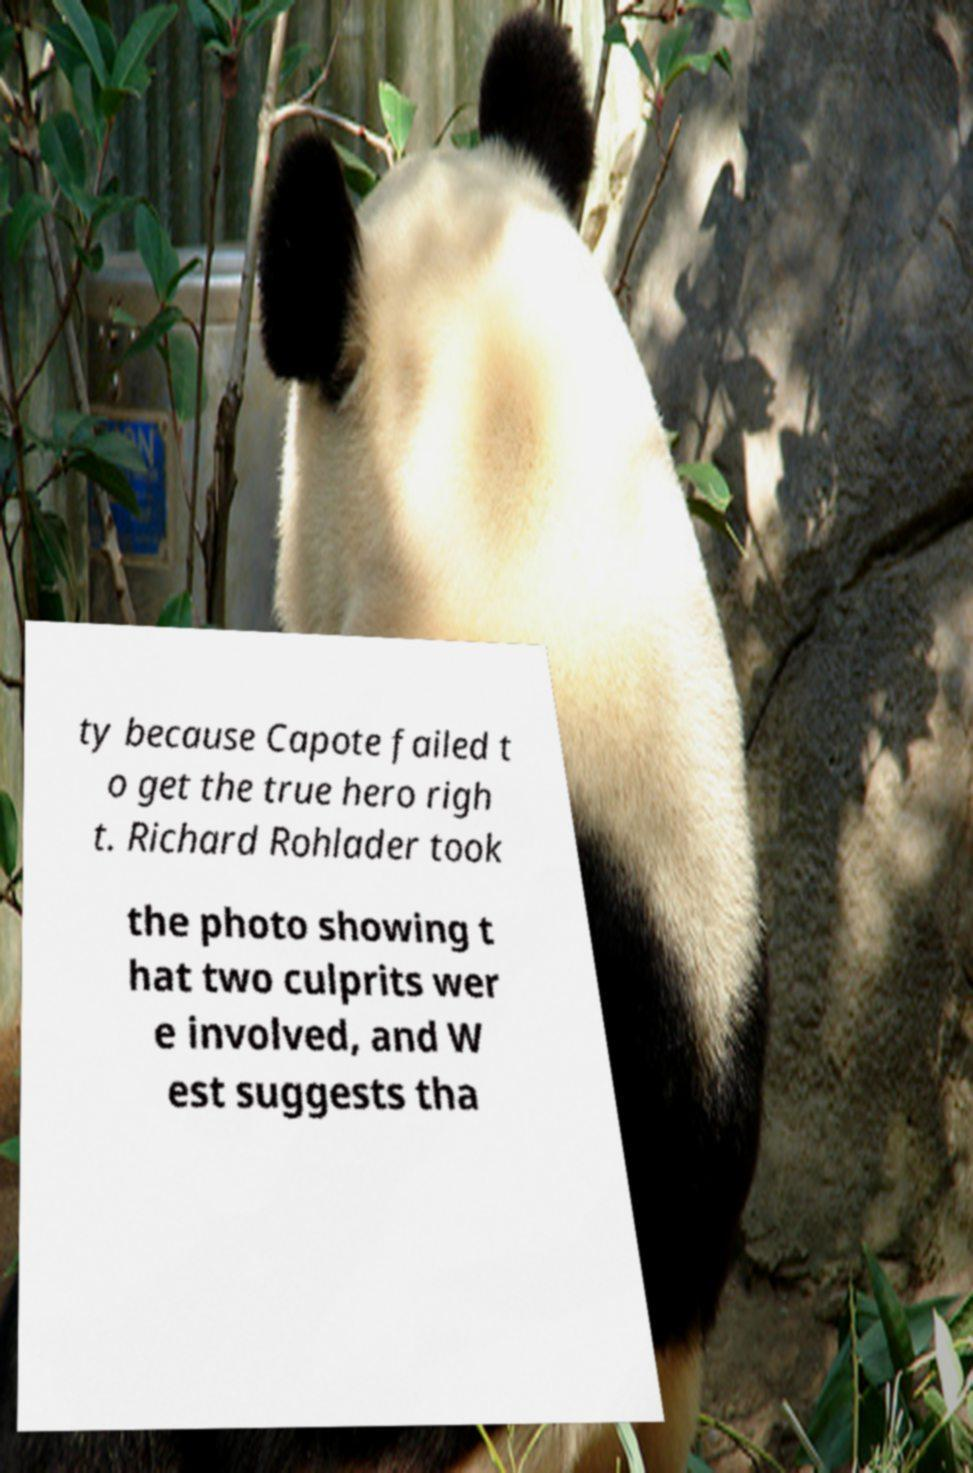I need the written content from this picture converted into text. Can you do that? ty because Capote failed t o get the true hero righ t. Richard Rohlader took the photo showing t hat two culprits wer e involved, and W est suggests tha 